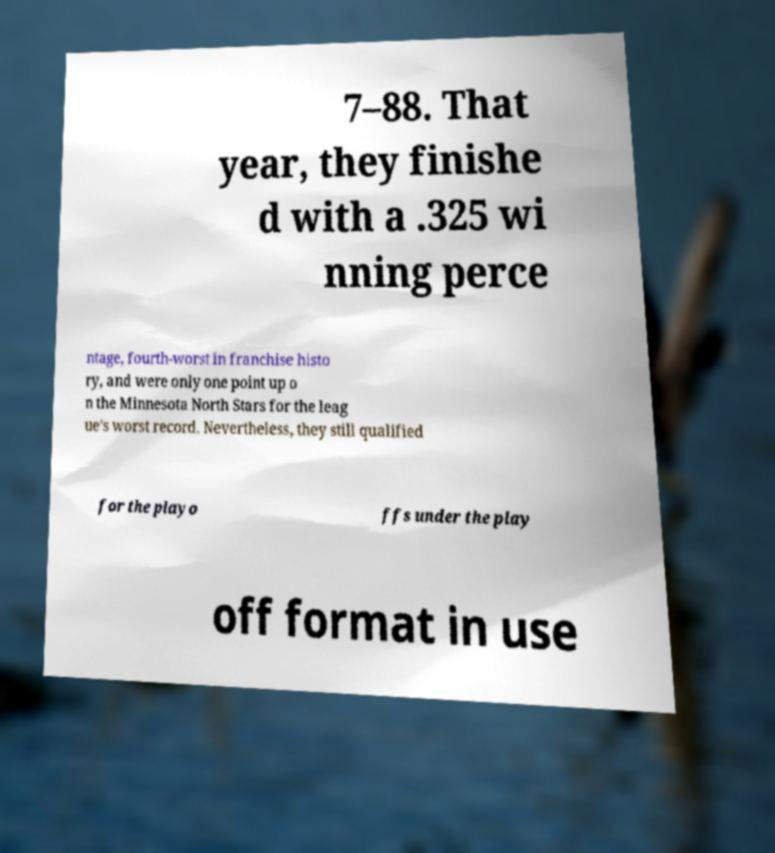I need the written content from this picture converted into text. Can you do that? 7–88. That year, they finishe d with a .325 wi nning perce ntage, fourth-worst in franchise histo ry, and were only one point up o n the Minnesota North Stars for the leag ue's worst record. Nevertheless, they still qualified for the playo ffs under the play off format in use 